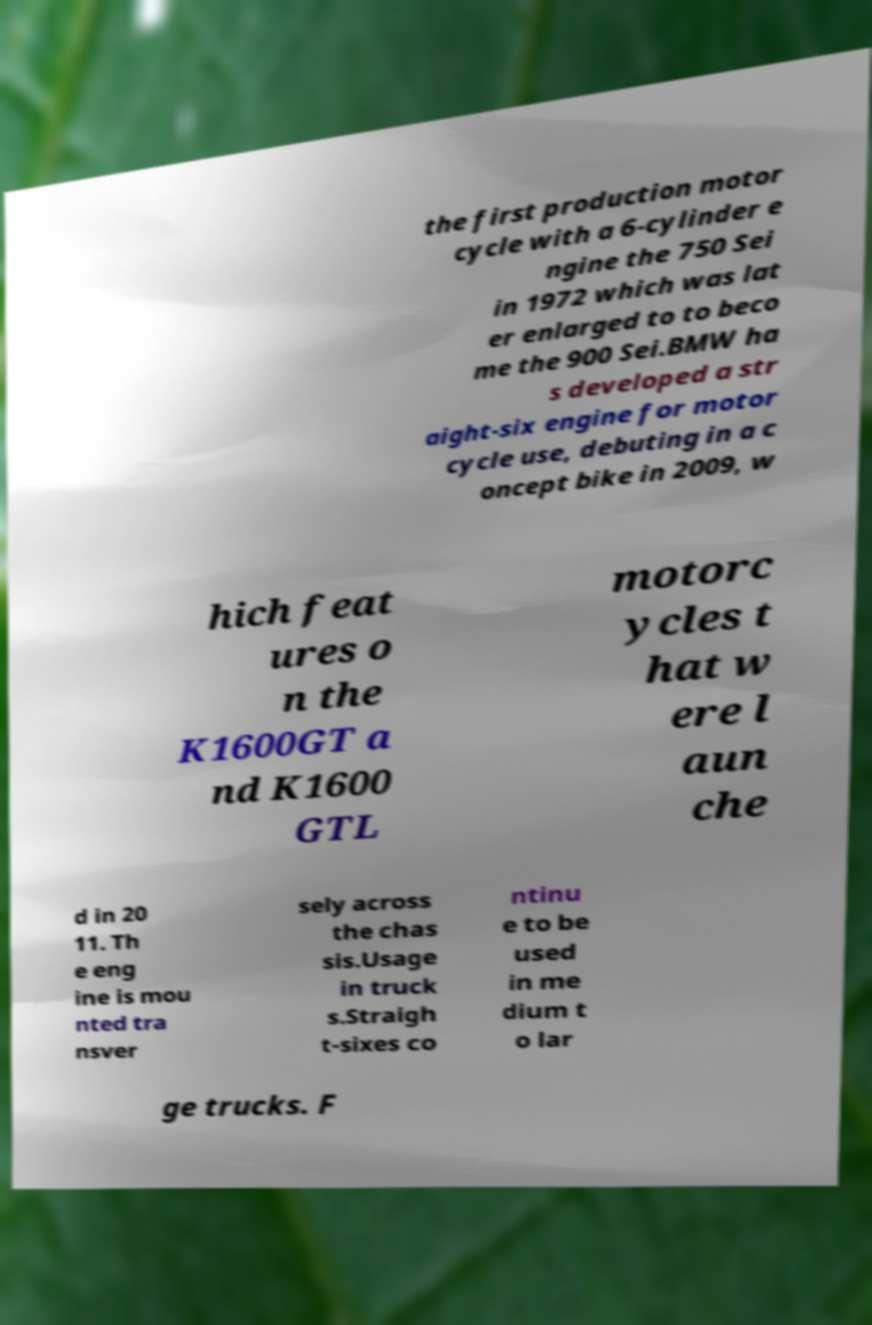I need the written content from this picture converted into text. Can you do that? the first production motor cycle with a 6-cylinder e ngine the 750 Sei in 1972 which was lat er enlarged to to beco me the 900 Sei.BMW ha s developed a str aight-six engine for motor cycle use, debuting in a c oncept bike in 2009, w hich feat ures o n the K1600GT a nd K1600 GTL motorc ycles t hat w ere l aun che d in 20 11. Th e eng ine is mou nted tra nsver sely across the chas sis.Usage in truck s.Straigh t-sixes co ntinu e to be used in me dium t o lar ge trucks. F 